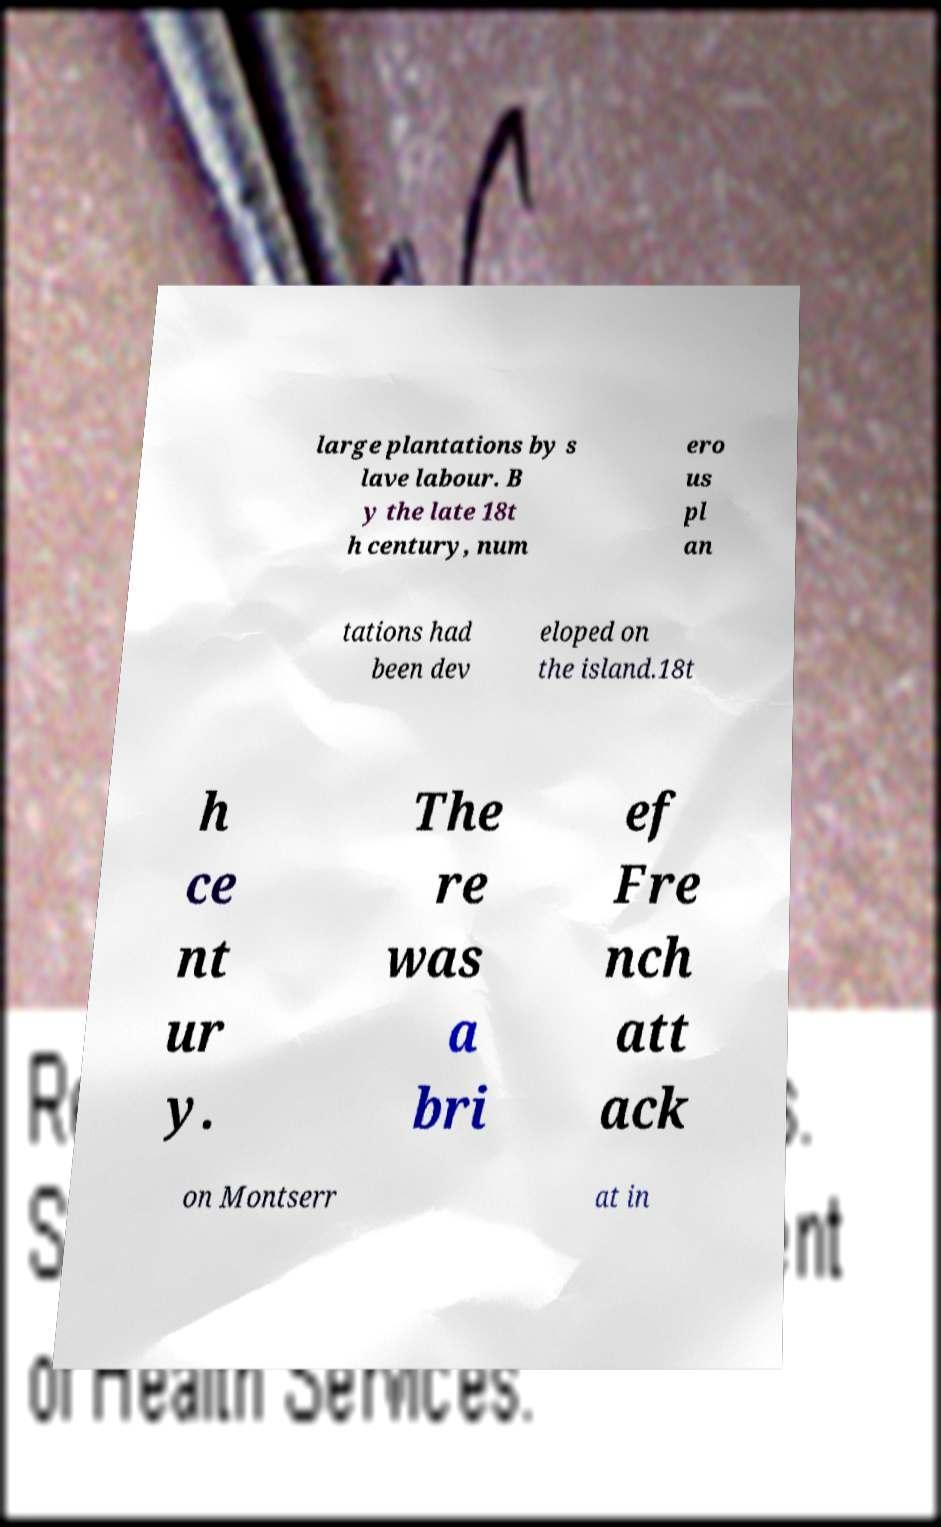Can you read and provide the text displayed in the image?This photo seems to have some interesting text. Can you extract and type it out for me? large plantations by s lave labour. B y the late 18t h century, num ero us pl an tations had been dev eloped on the island.18t h ce nt ur y. The re was a bri ef Fre nch att ack on Montserr at in 